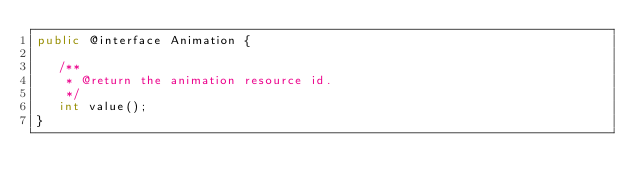<code> <loc_0><loc_0><loc_500><loc_500><_Java_>public @interface Animation {

   /**
    * @return the animation resource id.
    */
   int value();
}
</code> 